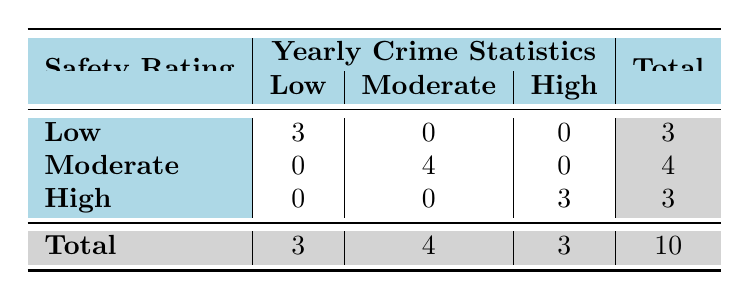What is the total number of neighborhoods with a low safety rating? There are three neighborhoods listed under the low safety rating category: Camden Town, Southwark, and Westminster.
Answer: 3 How many neighborhoods have a moderate safety rating? Looking at the moderate safety rating category, there are four neighborhoods: Islington, Brixton, Walthamstow, and Croydon.
Answer: 4 Do any neighborhoods with a high safety rating have yearly crime statistics above 500? Upon examining the high safety rating category, Camden Town and Greenwich have yearly crime statistics of 300 and 400, respectively, both of which are below 500. Therefore, the answer is no.
Answer: No What is the total number of neighborhoods represented in the table? The total count of neighborhoods is shown in the last row of the table. Adding the total for each safety rating category gives us 3 (low) + 4 (moderate) + 3 (high) = 10.
Answer: 10 What is the average yearly crime statistic for areas with a high safety rating? The total yearly crime statistics for high safety ratings is 300 + 400 + 200 = 900. There are 3 neighborhoods with a high safety rating, so the average is 900 / 3 = 300.
Answer: 300 What is the difference in the number of neighborhoods between low and high safety ratings? The number of neighborhoods with low safety ratings is 3, and for high safety ratings, it is 3. The difference is 3 (low) - 3 (high) = 0.
Answer: 0 Is Westminster the only neighborhood with a low safety rating? Checking the low safety rating category reveals there are three neighborhoods (Camden Town, Southwark, and Westminster), showing Westminster is not the only one.
Answer: No What percentage of the neighborhoods have a low safety rating? There are a total of 10 neighborhoods in the table, and 3 of them have a low safety rating. To find the percentage, we calculate (3 / 10) * 100 = 30%.
Answer: 30% 